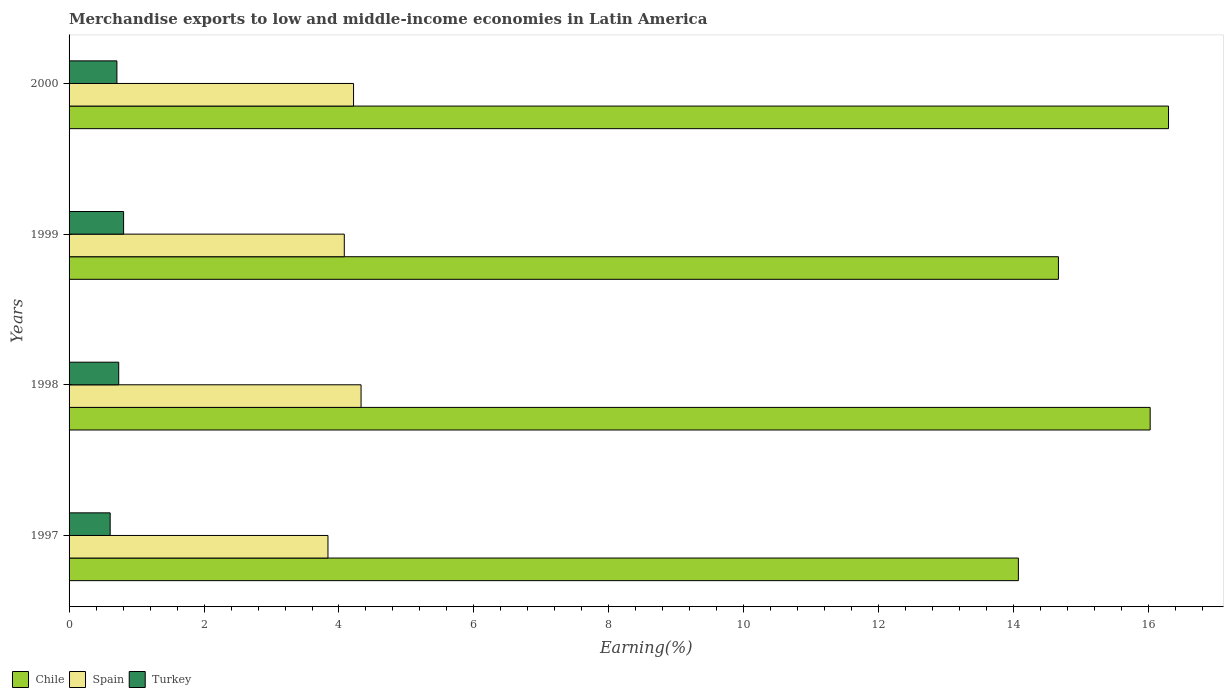How many different coloured bars are there?
Give a very brief answer. 3. Are the number of bars on each tick of the Y-axis equal?
Ensure brevity in your answer.  Yes. How many bars are there on the 4th tick from the top?
Offer a very short reply. 3. How many bars are there on the 3rd tick from the bottom?
Make the answer very short. 3. What is the percentage of amount earned from merchandise exports in Turkey in 1999?
Keep it short and to the point. 0.81. Across all years, what is the maximum percentage of amount earned from merchandise exports in Chile?
Ensure brevity in your answer.  16.29. Across all years, what is the minimum percentage of amount earned from merchandise exports in Chile?
Provide a short and direct response. 14.07. What is the total percentage of amount earned from merchandise exports in Spain in the graph?
Offer a very short reply. 16.46. What is the difference between the percentage of amount earned from merchandise exports in Chile in 1997 and that in 1999?
Give a very brief answer. -0.59. What is the difference between the percentage of amount earned from merchandise exports in Chile in 1998 and the percentage of amount earned from merchandise exports in Turkey in 1999?
Your response must be concise. 15.21. What is the average percentage of amount earned from merchandise exports in Turkey per year?
Offer a terse response. 0.72. In the year 1998, what is the difference between the percentage of amount earned from merchandise exports in Spain and percentage of amount earned from merchandise exports in Chile?
Offer a terse response. -11.69. What is the ratio of the percentage of amount earned from merchandise exports in Spain in 1998 to that in 2000?
Offer a terse response. 1.03. Is the percentage of amount earned from merchandise exports in Spain in 1999 less than that in 2000?
Offer a very short reply. Yes. Is the difference between the percentage of amount earned from merchandise exports in Spain in 1997 and 1999 greater than the difference between the percentage of amount earned from merchandise exports in Chile in 1997 and 1999?
Your response must be concise. Yes. What is the difference between the highest and the second highest percentage of amount earned from merchandise exports in Spain?
Give a very brief answer. 0.11. What is the difference between the highest and the lowest percentage of amount earned from merchandise exports in Spain?
Make the answer very short. 0.49. In how many years, is the percentage of amount earned from merchandise exports in Turkey greater than the average percentage of amount earned from merchandise exports in Turkey taken over all years?
Your response must be concise. 2. What does the 2nd bar from the top in 1998 represents?
Provide a succinct answer. Spain. Are all the bars in the graph horizontal?
Make the answer very short. Yes. How many years are there in the graph?
Provide a short and direct response. 4. What is the difference between two consecutive major ticks on the X-axis?
Your answer should be compact. 2. Are the values on the major ticks of X-axis written in scientific E-notation?
Keep it short and to the point. No. Does the graph contain any zero values?
Keep it short and to the point. No. Where does the legend appear in the graph?
Make the answer very short. Bottom left. What is the title of the graph?
Your answer should be compact. Merchandise exports to low and middle-income economies in Latin America. Does "Indonesia" appear as one of the legend labels in the graph?
Ensure brevity in your answer.  No. What is the label or title of the X-axis?
Ensure brevity in your answer.  Earning(%). What is the label or title of the Y-axis?
Your answer should be compact. Years. What is the Earning(%) in Chile in 1997?
Your response must be concise. 14.07. What is the Earning(%) of Spain in 1997?
Offer a terse response. 3.84. What is the Earning(%) of Turkey in 1997?
Your answer should be compact. 0.61. What is the Earning(%) in Chile in 1998?
Offer a terse response. 16.02. What is the Earning(%) in Spain in 1998?
Make the answer very short. 4.33. What is the Earning(%) in Turkey in 1998?
Your response must be concise. 0.74. What is the Earning(%) of Chile in 1999?
Ensure brevity in your answer.  14.66. What is the Earning(%) of Spain in 1999?
Your answer should be compact. 4.08. What is the Earning(%) in Turkey in 1999?
Provide a short and direct response. 0.81. What is the Earning(%) of Chile in 2000?
Keep it short and to the point. 16.29. What is the Earning(%) of Spain in 2000?
Your response must be concise. 4.22. What is the Earning(%) in Turkey in 2000?
Provide a short and direct response. 0.71. Across all years, what is the maximum Earning(%) of Chile?
Your answer should be compact. 16.29. Across all years, what is the maximum Earning(%) in Spain?
Ensure brevity in your answer.  4.33. Across all years, what is the maximum Earning(%) in Turkey?
Your response must be concise. 0.81. Across all years, what is the minimum Earning(%) of Chile?
Offer a terse response. 14.07. Across all years, what is the minimum Earning(%) of Spain?
Your answer should be very brief. 3.84. Across all years, what is the minimum Earning(%) in Turkey?
Make the answer very short. 0.61. What is the total Earning(%) of Chile in the graph?
Give a very brief answer. 61.05. What is the total Earning(%) of Spain in the graph?
Your response must be concise. 16.46. What is the total Earning(%) of Turkey in the graph?
Make the answer very short. 2.86. What is the difference between the Earning(%) of Chile in 1997 and that in 1998?
Offer a very short reply. -1.95. What is the difference between the Earning(%) in Spain in 1997 and that in 1998?
Your response must be concise. -0.49. What is the difference between the Earning(%) in Turkey in 1997 and that in 1998?
Keep it short and to the point. -0.13. What is the difference between the Earning(%) in Chile in 1997 and that in 1999?
Your answer should be very brief. -0.59. What is the difference between the Earning(%) in Spain in 1997 and that in 1999?
Provide a succinct answer. -0.24. What is the difference between the Earning(%) in Turkey in 1997 and that in 1999?
Provide a short and direct response. -0.2. What is the difference between the Earning(%) in Chile in 1997 and that in 2000?
Your answer should be compact. -2.23. What is the difference between the Earning(%) in Spain in 1997 and that in 2000?
Give a very brief answer. -0.38. What is the difference between the Earning(%) in Chile in 1998 and that in 1999?
Give a very brief answer. 1.36. What is the difference between the Earning(%) of Spain in 1998 and that in 1999?
Make the answer very short. 0.25. What is the difference between the Earning(%) of Turkey in 1998 and that in 1999?
Your response must be concise. -0.07. What is the difference between the Earning(%) of Chile in 1998 and that in 2000?
Your answer should be compact. -0.27. What is the difference between the Earning(%) of Spain in 1998 and that in 2000?
Ensure brevity in your answer.  0.11. What is the difference between the Earning(%) in Turkey in 1998 and that in 2000?
Ensure brevity in your answer.  0.03. What is the difference between the Earning(%) in Chile in 1999 and that in 2000?
Make the answer very short. -1.63. What is the difference between the Earning(%) in Spain in 1999 and that in 2000?
Offer a very short reply. -0.14. What is the difference between the Earning(%) of Turkey in 1999 and that in 2000?
Provide a succinct answer. 0.1. What is the difference between the Earning(%) in Chile in 1997 and the Earning(%) in Spain in 1998?
Give a very brief answer. 9.74. What is the difference between the Earning(%) of Chile in 1997 and the Earning(%) of Turkey in 1998?
Ensure brevity in your answer.  13.33. What is the difference between the Earning(%) of Spain in 1997 and the Earning(%) of Turkey in 1998?
Keep it short and to the point. 3.1. What is the difference between the Earning(%) in Chile in 1997 and the Earning(%) in Spain in 1999?
Your answer should be very brief. 9.99. What is the difference between the Earning(%) in Chile in 1997 and the Earning(%) in Turkey in 1999?
Give a very brief answer. 13.26. What is the difference between the Earning(%) of Spain in 1997 and the Earning(%) of Turkey in 1999?
Your answer should be very brief. 3.03. What is the difference between the Earning(%) in Chile in 1997 and the Earning(%) in Spain in 2000?
Offer a terse response. 9.85. What is the difference between the Earning(%) in Chile in 1997 and the Earning(%) in Turkey in 2000?
Offer a very short reply. 13.36. What is the difference between the Earning(%) in Spain in 1997 and the Earning(%) in Turkey in 2000?
Give a very brief answer. 3.13. What is the difference between the Earning(%) in Chile in 1998 and the Earning(%) in Spain in 1999?
Make the answer very short. 11.94. What is the difference between the Earning(%) in Chile in 1998 and the Earning(%) in Turkey in 1999?
Your answer should be very brief. 15.21. What is the difference between the Earning(%) in Spain in 1998 and the Earning(%) in Turkey in 1999?
Offer a very short reply. 3.52. What is the difference between the Earning(%) of Chile in 1998 and the Earning(%) of Spain in 2000?
Your answer should be very brief. 11.81. What is the difference between the Earning(%) of Chile in 1998 and the Earning(%) of Turkey in 2000?
Offer a very short reply. 15.31. What is the difference between the Earning(%) in Spain in 1998 and the Earning(%) in Turkey in 2000?
Your answer should be very brief. 3.62. What is the difference between the Earning(%) in Chile in 1999 and the Earning(%) in Spain in 2000?
Offer a terse response. 10.45. What is the difference between the Earning(%) in Chile in 1999 and the Earning(%) in Turkey in 2000?
Your answer should be very brief. 13.95. What is the difference between the Earning(%) of Spain in 1999 and the Earning(%) of Turkey in 2000?
Your answer should be compact. 3.37. What is the average Earning(%) of Chile per year?
Provide a short and direct response. 15.26. What is the average Earning(%) of Spain per year?
Offer a very short reply. 4.11. What is the average Earning(%) in Turkey per year?
Ensure brevity in your answer.  0.72. In the year 1997, what is the difference between the Earning(%) of Chile and Earning(%) of Spain?
Make the answer very short. 10.23. In the year 1997, what is the difference between the Earning(%) of Chile and Earning(%) of Turkey?
Offer a terse response. 13.46. In the year 1997, what is the difference between the Earning(%) of Spain and Earning(%) of Turkey?
Ensure brevity in your answer.  3.23. In the year 1998, what is the difference between the Earning(%) in Chile and Earning(%) in Spain?
Provide a short and direct response. 11.69. In the year 1998, what is the difference between the Earning(%) in Chile and Earning(%) in Turkey?
Offer a very short reply. 15.29. In the year 1998, what is the difference between the Earning(%) of Spain and Earning(%) of Turkey?
Give a very brief answer. 3.59. In the year 1999, what is the difference between the Earning(%) of Chile and Earning(%) of Spain?
Ensure brevity in your answer.  10.58. In the year 1999, what is the difference between the Earning(%) of Chile and Earning(%) of Turkey?
Offer a terse response. 13.85. In the year 1999, what is the difference between the Earning(%) of Spain and Earning(%) of Turkey?
Your answer should be compact. 3.27. In the year 2000, what is the difference between the Earning(%) in Chile and Earning(%) in Spain?
Offer a terse response. 12.08. In the year 2000, what is the difference between the Earning(%) of Chile and Earning(%) of Turkey?
Offer a very short reply. 15.58. In the year 2000, what is the difference between the Earning(%) of Spain and Earning(%) of Turkey?
Your answer should be very brief. 3.51. What is the ratio of the Earning(%) in Chile in 1997 to that in 1998?
Provide a succinct answer. 0.88. What is the ratio of the Earning(%) in Spain in 1997 to that in 1998?
Offer a very short reply. 0.89. What is the ratio of the Earning(%) of Turkey in 1997 to that in 1998?
Your answer should be compact. 0.83. What is the ratio of the Earning(%) of Chile in 1997 to that in 1999?
Your response must be concise. 0.96. What is the ratio of the Earning(%) of Spain in 1997 to that in 1999?
Offer a terse response. 0.94. What is the ratio of the Earning(%) of Turkey in 1997 to that in 1999?
Ensure brevity in your answer.  0.75. What is the ratio of the Earning(%) of Chile in 1997 to that in 2000?
Your answer should be compact. 0.86. What is the ratio of the Earning(%) of Spain in 1997 to that in 2000?
Your response must be concise. 0.91. What is the ratio of the Earning(%) in Turkey in 1997 to that in 2000?
Offer a very short reply. 0.86. What is the ratio of the Earning(%) of Chile in 1998 to that in 1999?
Make the answer very short. 1.09. What is the ratio of the Earning(%) of Spain in 1998 to that in 1999?
Offer a terse response. 1.06. What is the ratio of the Earning(%) of Turkey in 1998 to that in 1999?
Your response must be concise. 0.91. What is the ratio of the Earning(%) in Chile in 1998 to that in 2000?
Your answer should be very brief. 0.98. What is the ratio of the Earning(%) in Spain in 1998 to that in 2000?
Provide a succinct answer. 1.03. What is the ratio of the Earning(%) of Turkey in 1998 to that in 2000?
Your answer should be very brief. 1.04. What is the ratio of the Earning(%) of Chile in 1999 to that in 2000?
Provide a succinct answer. 0.9. What is the ratio of the Earning(%) in Spain in 1999 to that in 2000?
Offer a terse response. 0.97. What is the ratio of the Earning(%) in Turkey in 1999 to that in 2000?
Keep it short and to the point. 1.14. What is the difference between the highest and the second highest Earning(%) in Chile?
Provide a succinct answer. 0.27. What is the difference between the highest and the second highest Earning(%) of Spain?
Offer a very short reply. 0.11. What is the difference between the highest and the second highest Earning(%) of Turkey?
Your answer should be very brief. 0.07. What is the difference between the highest and the lowest Earning(%) of Chile?
Offer a very short reply. 2.23. What is the difference between the highest and the lowest Earning(%) of Spain?
Offer a terse response. 0.49. What is the difference between the highest and the lowest Earning(%) of Turkey?
Provide a short and direct response. 0.2. 